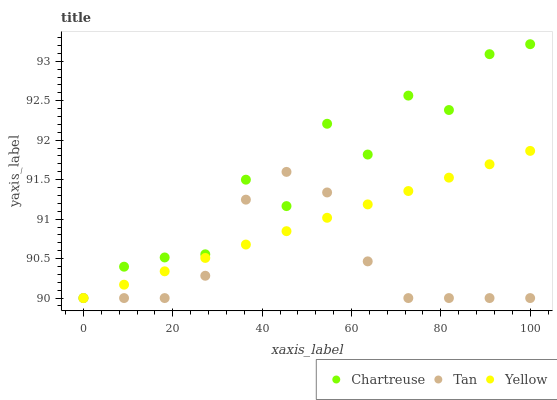Does Tan have the minimum area under the curve?
Answer yes or no. Yes. Does Chartreuse have the maximum area under the curve?
Answer yes or no. Yes. Does Yellow have the minimum area under the curve?
Answer yes or no. No. Does Yellow have the maximum area under the curve?
Answer yes or no. No. Is Yellow the smoothest?
Answer yes or no. Yes. Is Chartreuse the roughest?
Answer yes or no. Yes. Is Tan the smoothest?
Answer yes or no. No. Is Tan the roughest?
Answer yes or no. No. Does Chartreuse have the lowest value?
Answer yes or no. Yes. Does Chartreuse have the highest value?
Answer yes or no. Yes. Does Yellow have the highest value?
Answer yes or no. No. Does Yellow intersect Chartreuse?
Answer yes or no. Yes. Is Yellow less than Chartreuse?
Answer yes or no. No. Is Yellow greater than Chartreuse?
Answer yes or no. No. 